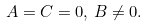Convert formula to latex. <formula><loc_0><loc_0><loc_500><loc_500>A = C = 0 , \, B \neq 0 .</formula> 